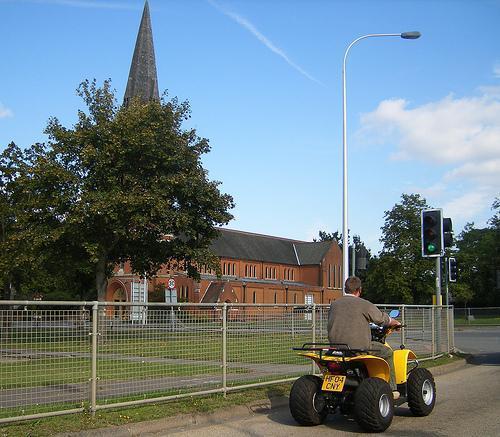How many automobiles are in this picture?
Give a very brief answer. 1. How many wheels does the automobile have?
Give a very brief answer. 4. 